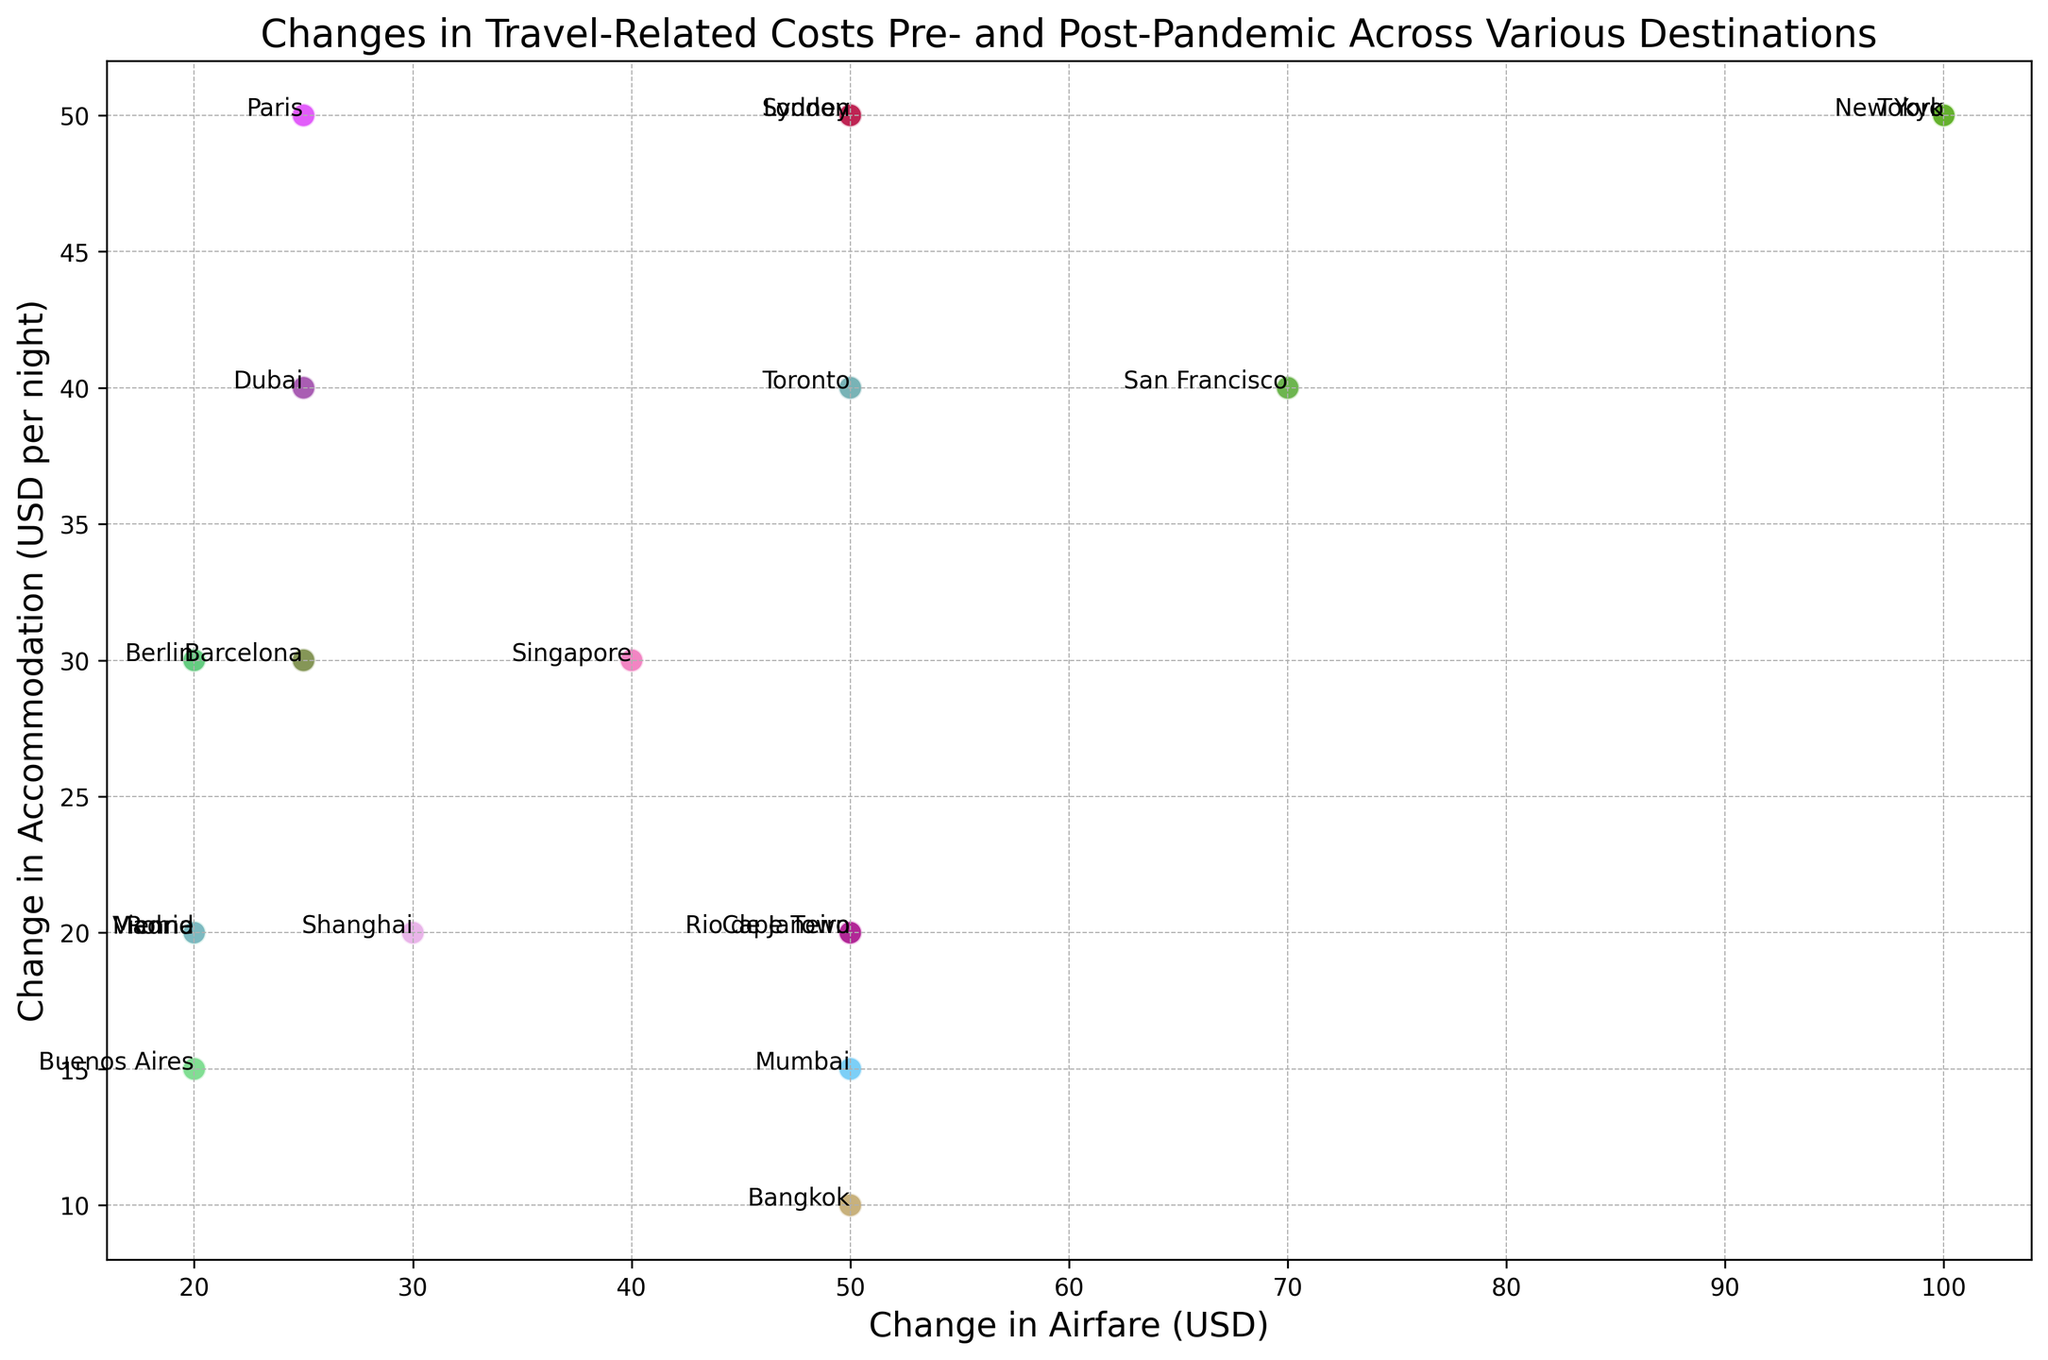Which destination has the largest increase in airfare? To find this, look at the scatter plot and find the point that is farthest to the right on the x-axis. The largest increase in airfare is associated with Tokyo, where the airfare change is +100 USD.
Answer: Tokyo Which destination has the smallest increase in accommodation costs? To determine this, find the point that is farthest to the bottom on the y-axis of the scatter plot. The smallest increase in accommodation costs is associated with Bangkok, where the change is +10 USD.
Answer: Bangkok How many destinations show a change in airfare that is equal to or greater than 100 USD? To answer this, count the number of points where the x-coordinate (airfare change) is 100 or more. There are 2 points: Tokyo and Sydney.
Answer: 2 Which two destinations have changes in both airfare and accommodation closest to (50, 50)? Identify the points on the scatter plot that are closest to the coordinates (50, 50). By evaluating visually, New York and Singapore are the closest in terms of both airfare and accommodation.
Answer: New York, Singapore What is the average increase in accommodation costs across all destinations? Calculate the average by summing all the y-values (accommodation changes) and dividing by the number of destinations. The sum of accommodation increases is 965, and there are 20 destinations. So, the average = 965 / 20 = 48.25 USD per night.
Answer: 48.25 Which destination has the smallest combination of changes (sum of changes in airfare and accommodation)? Sum the x and y values for each point and find the smallest value. Rio de Janeiro has changes of 50 (airfare) and 20 (accommodation), giving a combined change of 70, which is the smallest.
Answer: Rio de Janeiro Which destinations show an increase in accommodation costs but a decrease in airfare costs? Identify the points where the y-value is positive (increase in accommodation) and the x-value is negative (decrease in airfare). There are no points in the scatter plot that meet this criterion.
Answer: None Which destination had the highest accommodation increase relative to its airfare increase? (i.e., some combination of cost delta ratios) To find this, you can compare the accommodation change to the airfare change for each destination visually and possibly numerically, but visually, the ratio seems highest for San Francisco.
Answer: San Francisco Are there any destinations where both airfare and accommodation costs increased by exactly the same amount? Look for points where the x and y values are equal. There are no such points where both costs increased by the exact same amount.
Answer: None Which destinations lie in the top-right quadrant of the plot, indicating increases in both airfare and accommodation costs? Identify the points that have positive x and y values, meaning both costs have increased. These include New York, London, Tokyo, Paris, Rome, Sydney, Cape Town, Barcelona, Bangkok, Dubai, Singapore, Berlin, San Francisco, Rio de Janeiro, Mumbai, Toronto, Madrid, Vienna, Buenos Aires, and Shanghai.
Answer: New York, London, Tokyo, Paris, Rome, Sydney, Cape Town, Barcelona, Bangkok, Dubai, Singapore, Berlin, San Francisco, Rio de Janeiro, Mumbai, Toronto, Madrid, Vienna, Buenos Aires, Shanghai 